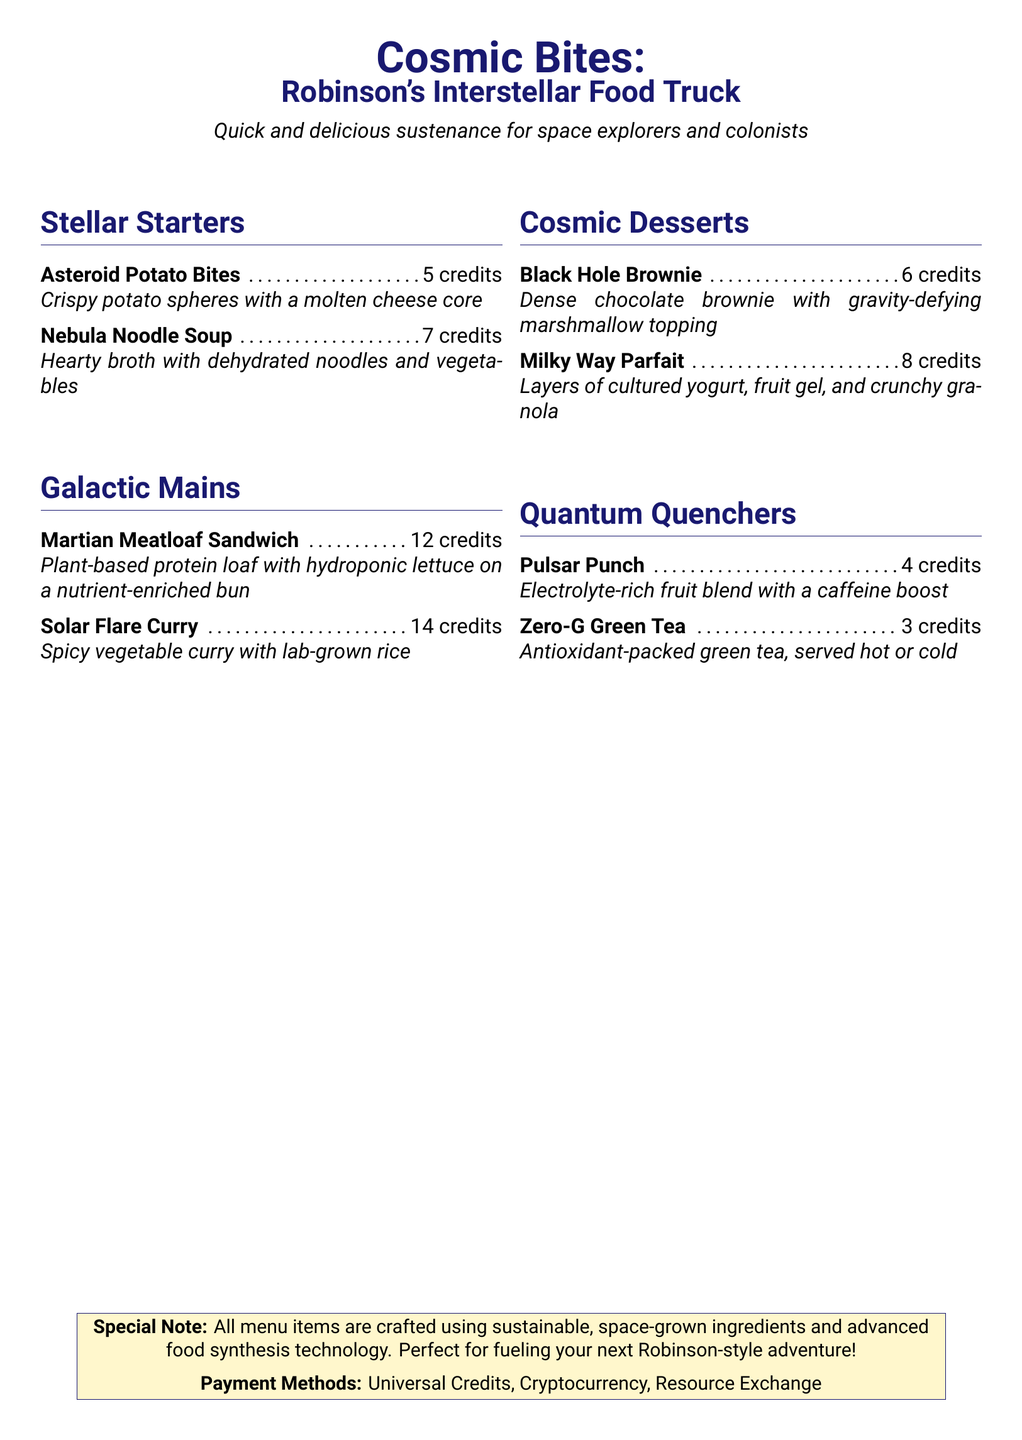what are the Stellar Starters? The Stellar Starters section lists the first two items on the menu, which are appetizers suitable for space explorers.
Answer: Asteroid Potato Bites, Nebula Noodle Soup what is the price of the Milky Way Parfait? The menu explicitly states the price for each dessert, including the Milky Way Parfait.
Answer: 8 credits which main dish contains plant-based protein? This question seeks to identify the main dish that uses plant-based ingredients, reflecting a sustainable approach.
Answer: Martian Meatloaf Sandwich how many items are offered in total? The total number of items is derived from the menu sections: Stellar Starters, Galactic Mains, Cosmic Desserts, and Quantum Quenchers.
Answer: 8 what color theme is used for the menu title? The document indicates the color used for the menu title, highlighting the theme adopted.
Answer: spaceblue what beverage has the lowest price? This question inquires about the drink with the minimum cost based on the prices listed for Quantum Quenchers.
Answer: Zero-G Green Tea which dessert has a chocolate base? The question requires pinpointing the dessert that features chocolate prominently, reflecting its ingredients.
Answer: Black Hole Brownie how is the food sourced? The menu includes a special note detailing the sourcing method for the food items offered.
Answer: sustainable, space-grown ingredients 